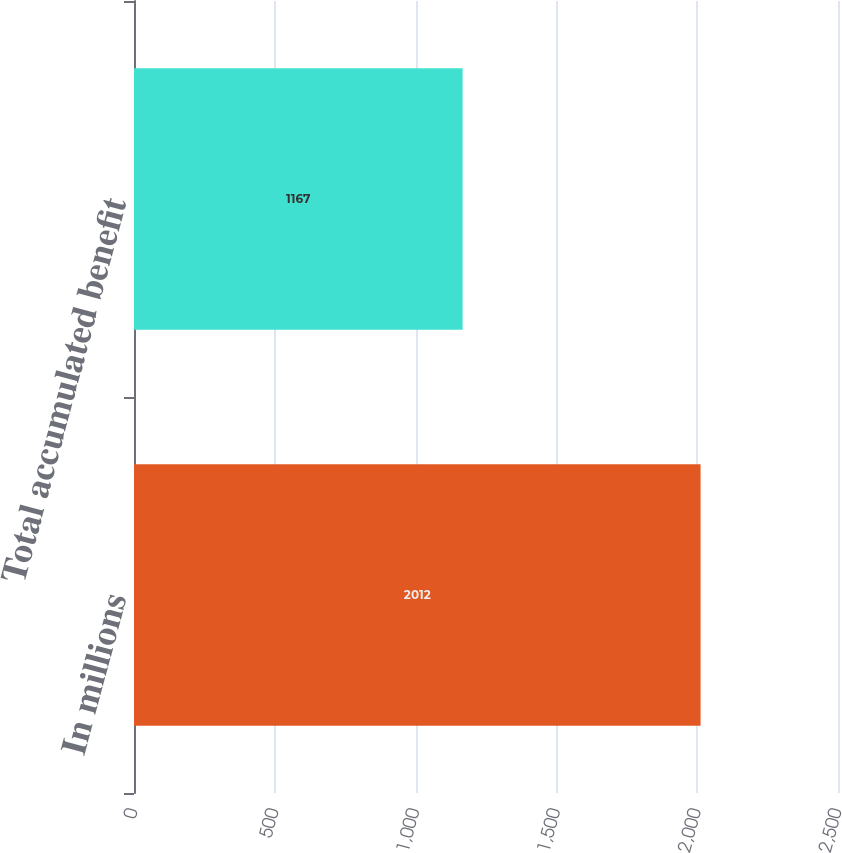Convert chart. <chart><loc_0><loc_0><loc_500><loc_500><bar_chart><fcel>In millions<fcel>Total accumulated benefit<nl><fcel>2012<fcel>1167<nl></chart> 